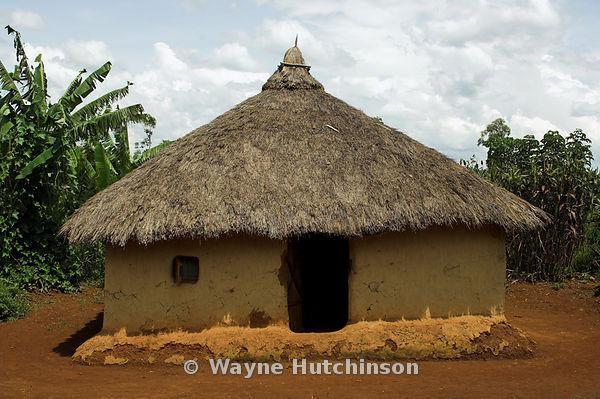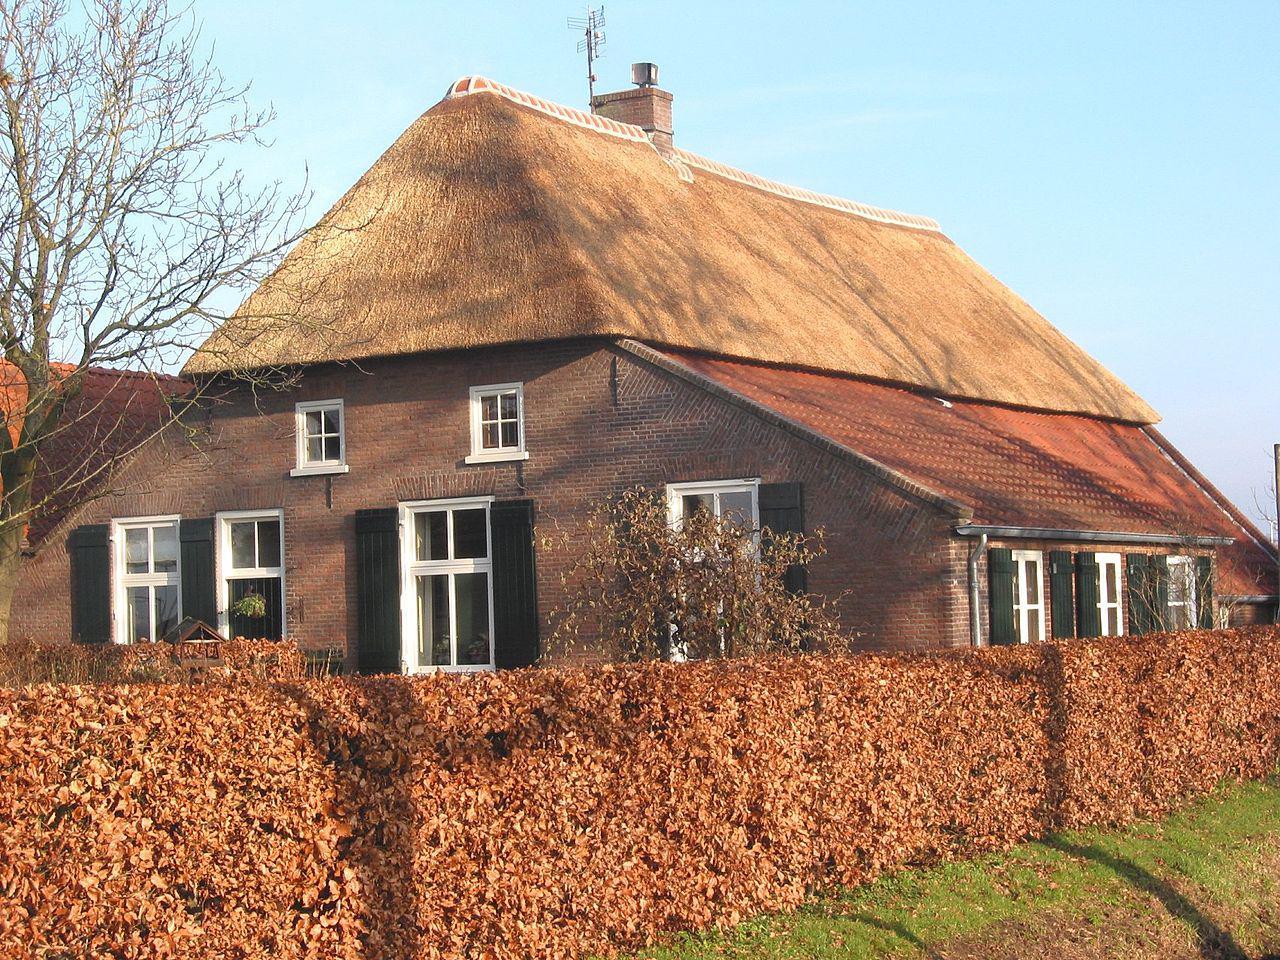The first image is the image on the left, the second image is the image on the right. Analyze the images presented: Is the assertion "An image shows a chimney-less roof that curves around an upper window, creating a semicircle arch over it." valid? Answer yes or no. No. 